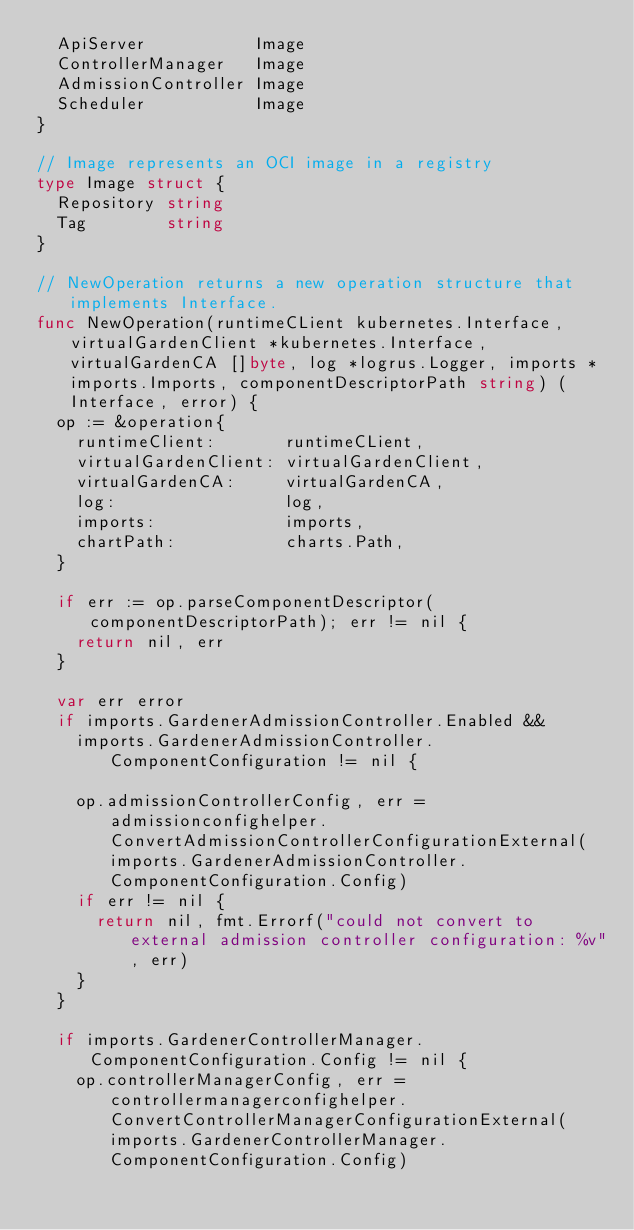Convert code to text. <code><loc_0><loc_0><loc_500><loc_500><_Go_>	ApiServer           Image
	ControllerManager   Image
	AdmissionController Image
	Scheduler           Image
}

// Image represents an OCI image in a registry
type Image struct {
	Repository string
	Tag        string
}

// NewOperation returns a new operation structure that implements Interface.
func NewOperation(runtimeCLient kubernetes.Interface, virtualGardenClient *kubernetes.Interface, virtualGardenCA []byte, log *logrus.Logger, imports *imports.Imports, componentDescriptorPath string) (Interface, error) {
	op := &operation{
		runtimeClient:       runtimeCLient,
		virtualGardenClient: virtualGardenClient,
		virtualGardenCA:     virtualGardenCA,
		log:                 log,
		imports:             imports,
		chartPath:           charts.Path,
	}

	if err := op.parseComponentDescriptor(componentDescriptorPath); err != nil {
		return nil, err
	}

	var err error
	if imports.GardenerAdmissionController.Enabled &&
		imports.GardenerAdmissionController.ComponentConfiguration != nil {

		op.admissionControllerConfig, err = admissionconfighelper.ConvertAdmissionControllerConfigurationExternal(imports.GardenerAdmissionController.ComponentConfiguration.Config)
		if err != nil {
			return nil, fmt.Errorf("could not convert to external admission controller configuration: %v", err)
		}
	}

	if imports.GardenerControllerManager.ComponentConfiguration.Config != nil {
		op.controllerManagerConfig, err = controllermanagerconfighelper.ConvertControllerManagerConfigurationExternal(imports.GardenerControllerManager.ComponentConfiguration.Config)</code> 